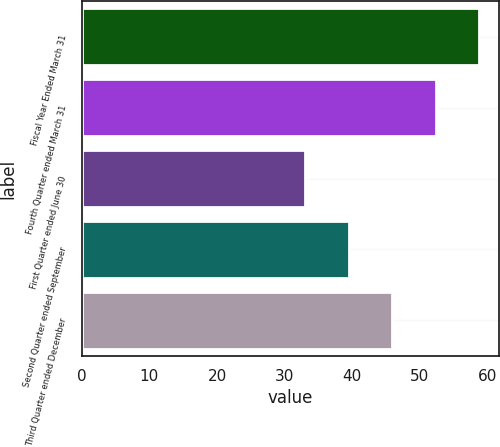<chart> <loc_0><loc_0><loc_500><loc_500><bar_chart><fcel>Fiscal Year Ended March 31<fcel>Fourth Quarter ended March 31<fcel>First Quarter ended June 30<fcel>Second Quarter ended September<fcel>Third Quarter ended December<nl><fcel>58.82<fcel>52.38<fcel>33.06<fcel>39.5<fcel>45.94<nl></chart> 